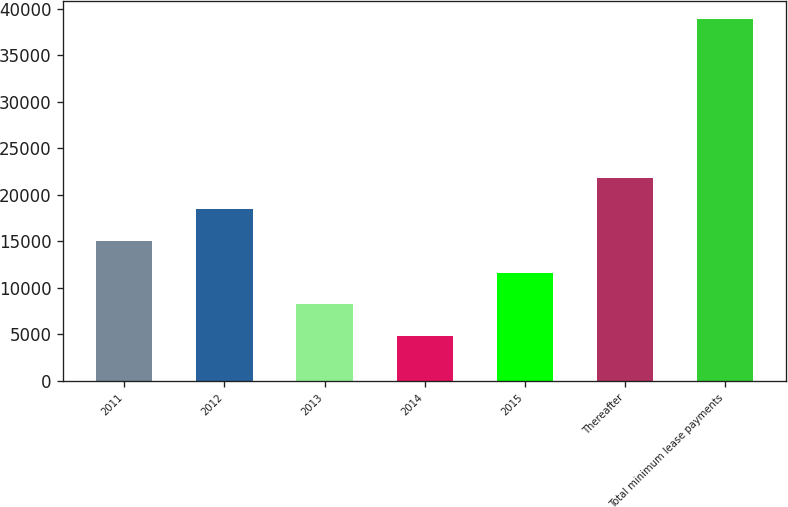<chart> <loc_0><loc_0><loc_500><loc_500><bar_chart><fcel>2011<fcel>2012<fcel>2013<fcel>2014<fcel>2015<fcel>Thereafter<fcel>Total minimum lease payments<nl><fcel>15023.1<fcel>18431.8<fcel>8205.7<fcel>4797<fcel>11614.4<fcel>21840.5<fcel>38884<nl></chart> 